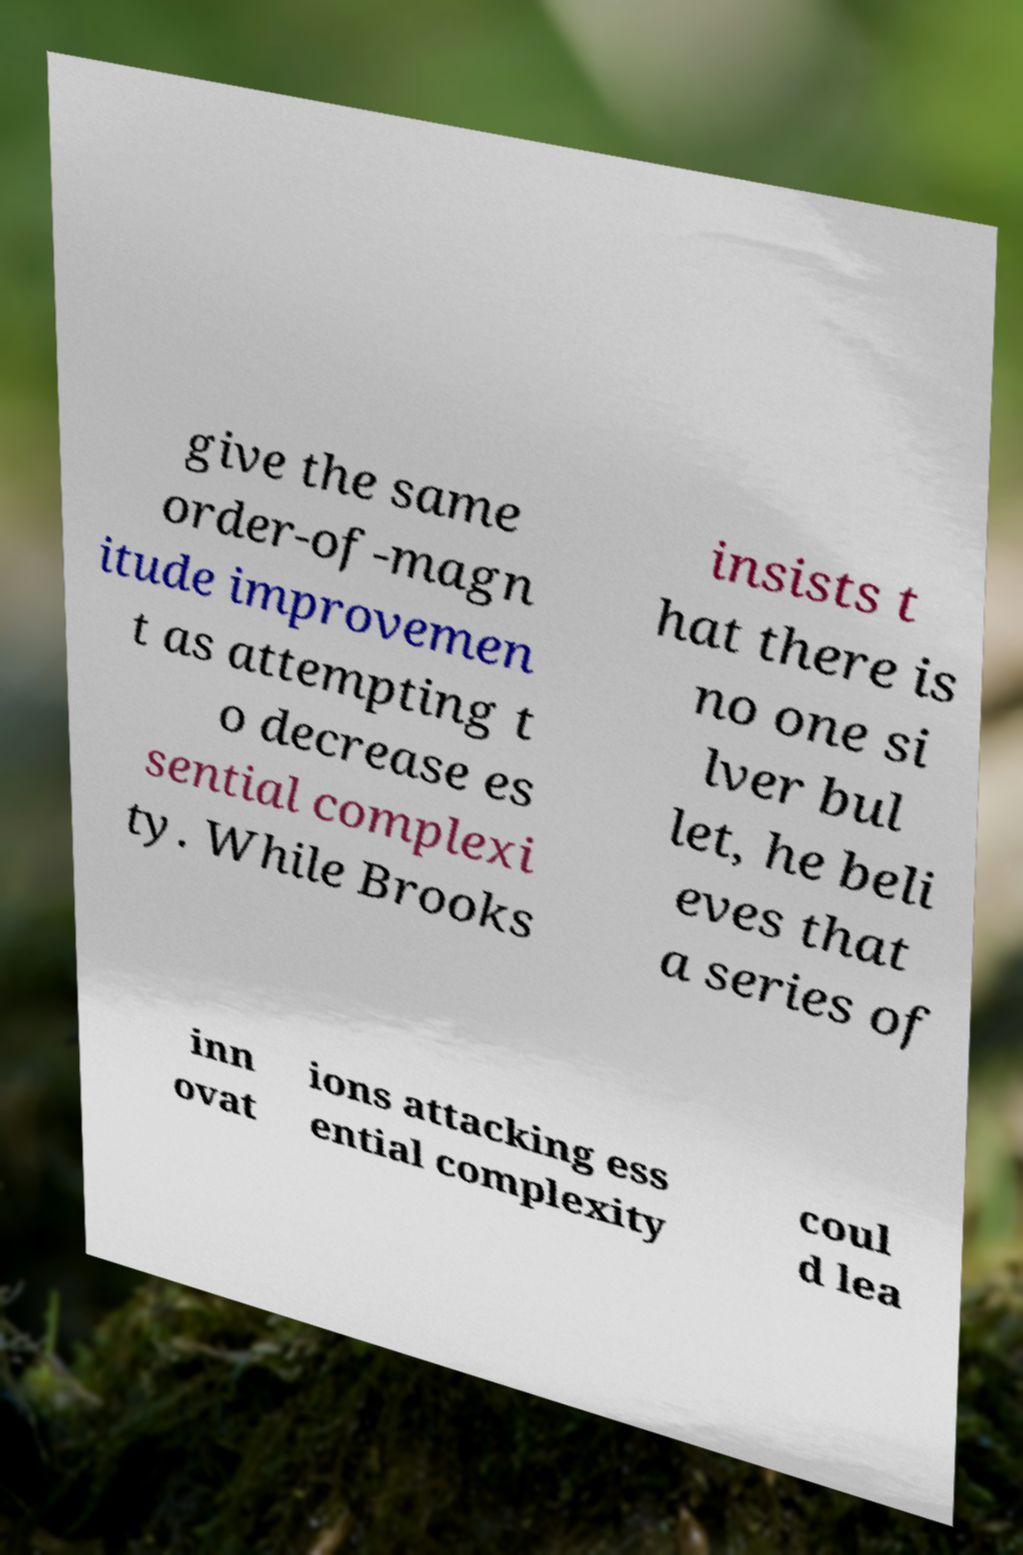Could you extract and type out the text from this image? give the same order-of-magn itude improvemen t as attempting t o decrease es sential complexi ty. While Brooks insists t hat there is no one si lver bul let, he beli eves that a series of inn ovat ions attacking ess ential complexity coul d lea 